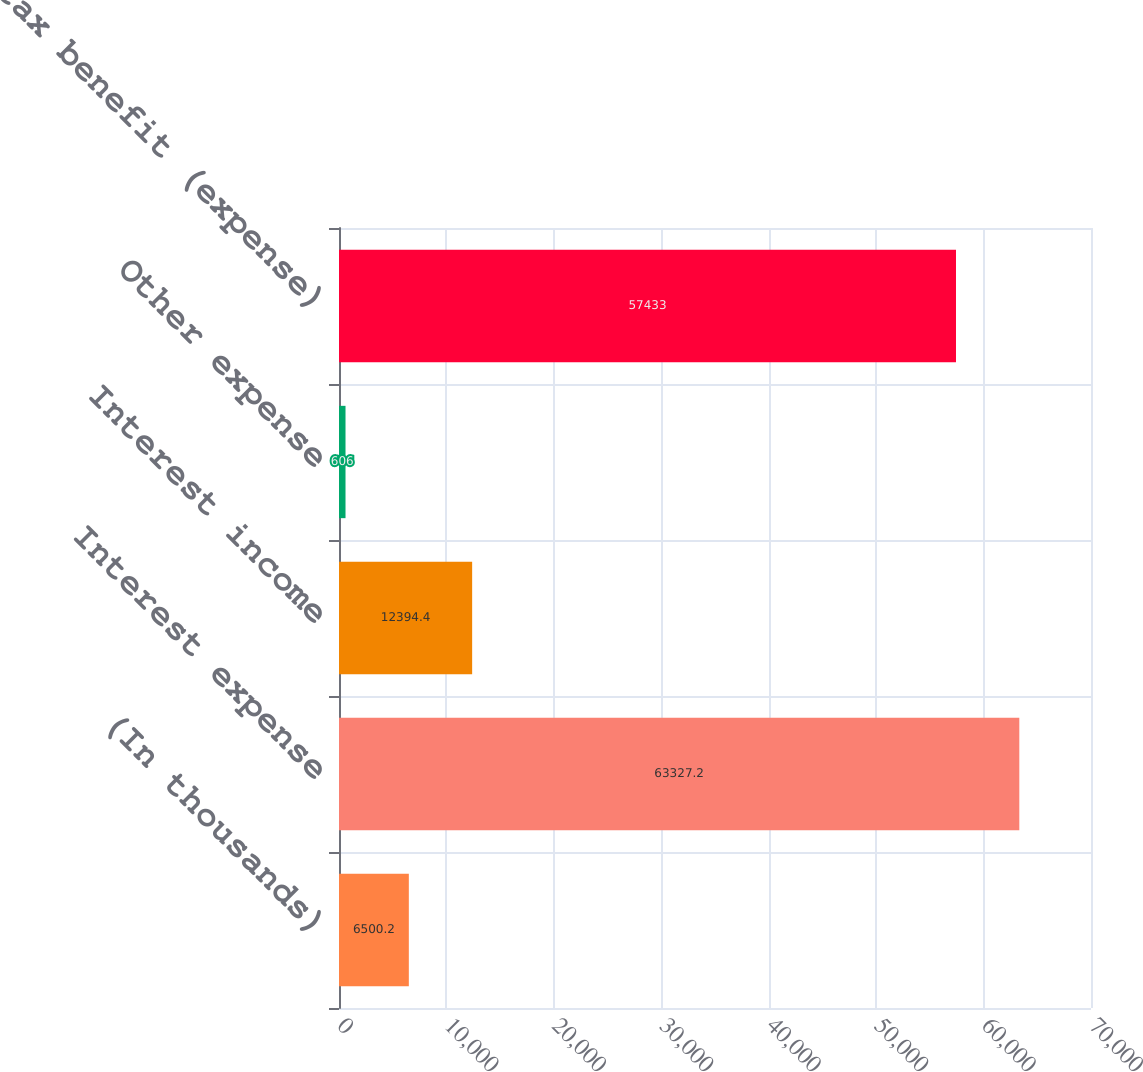<chart> <loc_0><loc_0><loc_500><loc_500><bar_chart><fcel>(In thousands)<fcel>Interest expense<fcel>Interest income<fcel>Other expense<fcel>Income tax benefit (expense)<nl><fcel>6500.2<fcel>63327.2<fcel>12394.4<fcel>606<fcel>57433<nl></chart> 